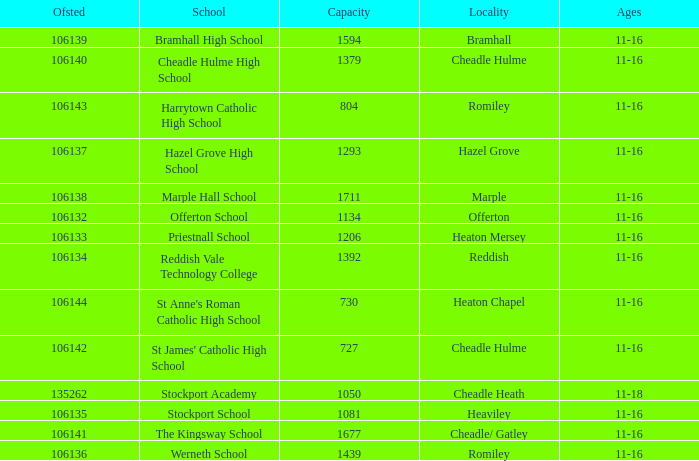Which School has a Capacity larger than 730, and an Ofsted smaller than 106135, and a Locality of heaton mersey? Priestnall School. 